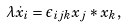<formula> <loc_0><loc_0><loc_500><loc_500>\lambda \dot { x } _ { i } = \epsilon _ { i j k } x _ { j } \ast x _ { k } ,</formula> 